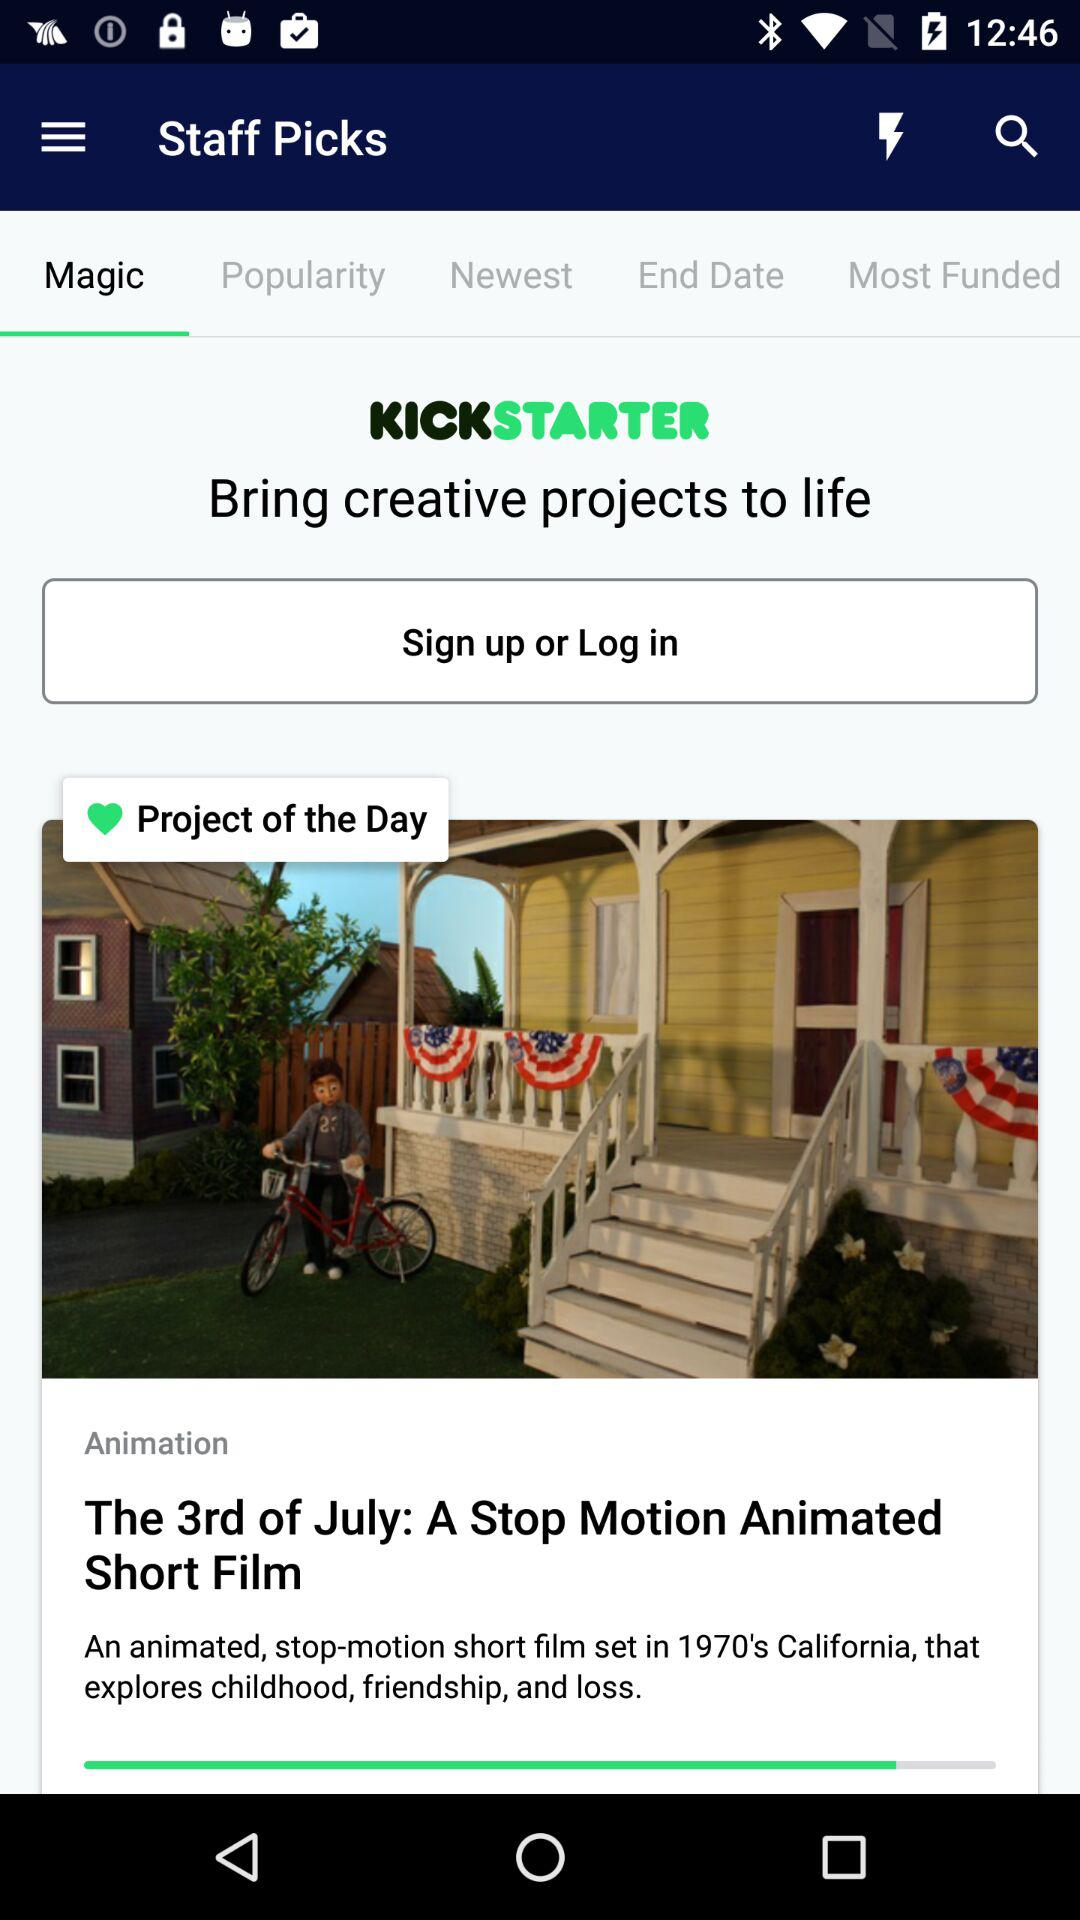Which tab am I on? You are on the "Magic" tab. 